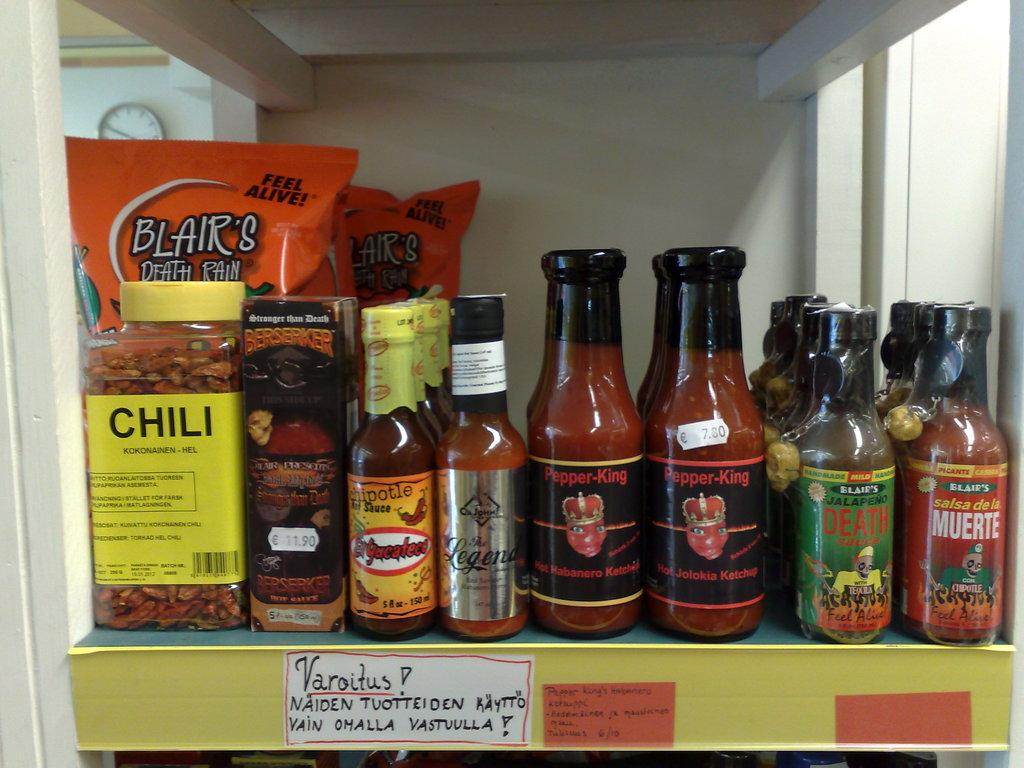<image>
Provide a brief description of the given image. A shelf of different chili and hot sauce including Blair's, Muerte Death, and Pepper-King chipotle sauce. 